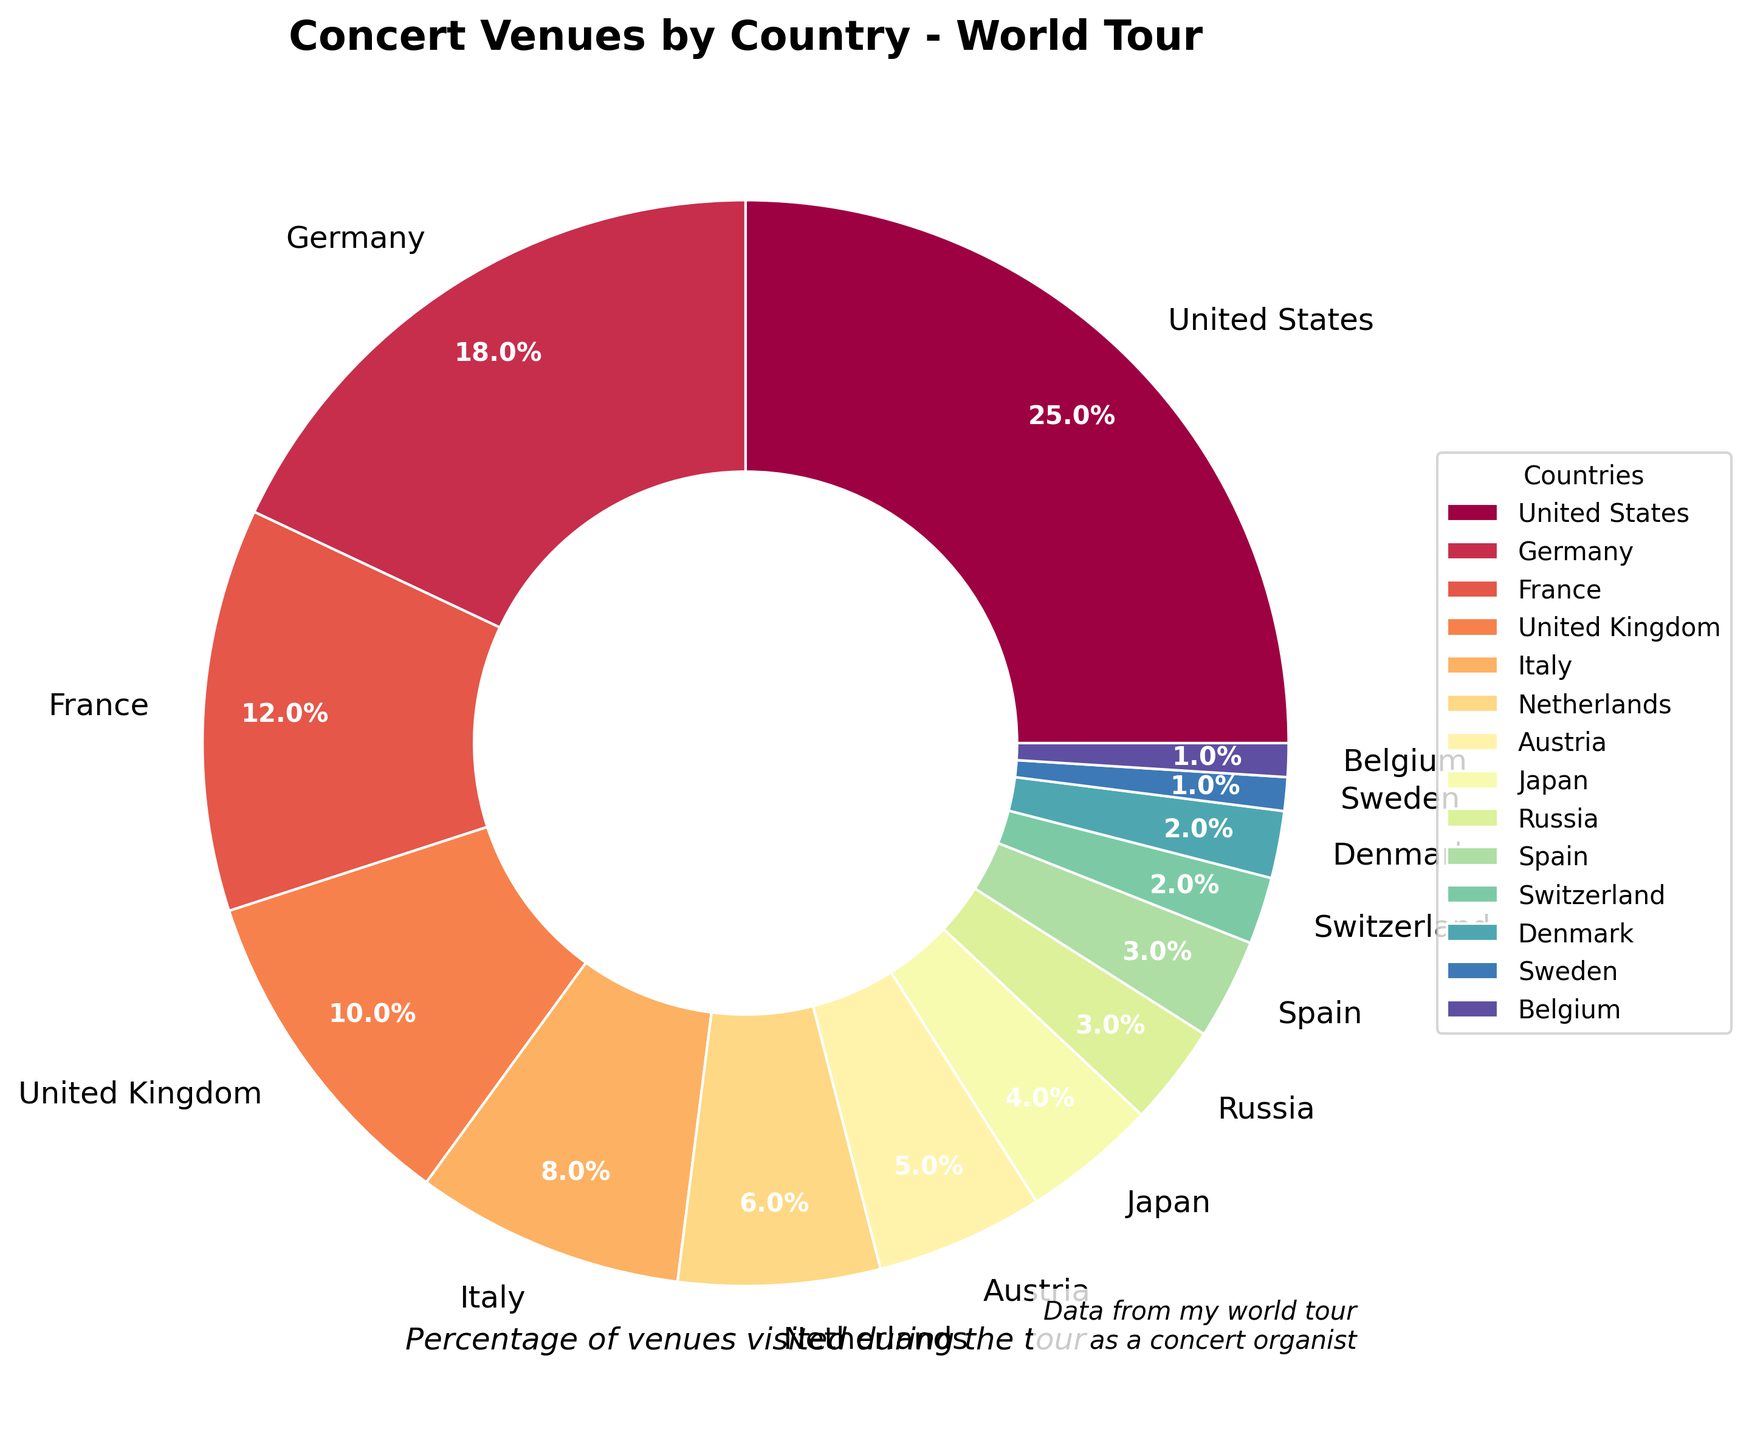Which country has the highest percentage of concert venues visited? The wedge with the highest percentage label is the United States, showing a percentage of 25%.
Answer: United States What is the combined percentage of concert venues visited in Germany and France? Add the percentages for Germany (18%) and France (12%). The combined percentage is 18% + 12% = 30%.
Answer: 30% Which countries have equal percentages of concert venues visited? The wedges labeled as Spain and Russia both have 3%. Additionally, Denmark and Switzerland each have 2%, and Belgium and Sweden each have 1%.
Answer: Spain and Russia; Denmark and Switzerland; Belgium and Sweden What percentage of concert venues were visited in European countries? Add the percentages for Germany (18%), France (12%), United Kingdom (10%), Italy (8%), Netherlands (6%), Austria (5%), Russia (3%), Spain (3%), Switzerland (2%), Denmark (2%), Sweden (1%), and Belgium (1%). The total is 71%.
Answer: 71% How does the percentage of venues visited in Japan compare to that in the Netherlands? Japan has 4% and the Netherlands has 6%. Comparing these values, the Netherlands has a higher percentage than Japan.
Answer: The Netherlands has a higher percentage than Japan What is the average percentage of concert venues visited in Italy, Austria, and the Netherlands? Add the percentages for Italy (8%), Austria (5%), and Netherlands (6%) to get a total of 19%. Divide this by 3 to get the average: 19% / 3 ≈ 6.33%.
Answer: Approximately 6.33% Which country has a smaller percentage: Switzerland or Denmark? Both Switzerland and Denmark have the same percentage of 2%.
Answer: They are equal By how much does the percentage of concert venues visited in the United States exceed that in Germany? Subtract the percentage of Germany (18%) from the percentage of the United States (25%). 25% - 18% = 7%.
Answer: 7% What is the total percentage of venues visited in the United Kingdom and Italy? Add the percentages for the United Kingdom (10%) and Italy (8%). 10% + 8% = 18%.
Answer: 18% Is the percentage of concert venues visited in France more or less than double that in Japan? The percentage in France is 12%, while in Japan it is 4%. Double of Japan's percentage is 2 * 4% = 8%. Comparing these, 12% (France) is more than 8% (double of Japan).
Answer: More 